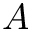<formula> <loc_0><loc_0><loc_500><loc_500>A</formula> 